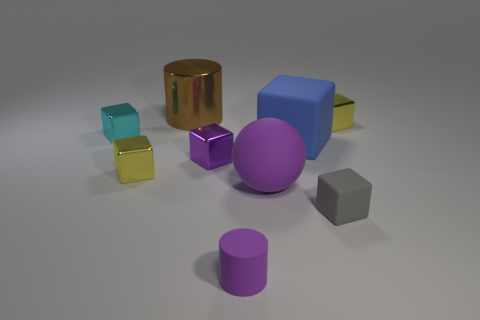What number of other objects are there of the same material as the large brown object?
Provide a succinct answer. 4. Is the material of the large cube the same as the yellow thing to the left of the large matte ball?
Your response must be concise. No. Is the number of big matte cubes that are behind the blue rubber cube less than the number of metal cubes on the left side of the small purple block?
Keep it short and to the point. Yes. There is a metal block behind the cyan thing; what color is it?
Provide a short and direct response. Yellow. How many other things are there of the same color as the large rubber block?
Keep it short and to the point. 0. There is a metallic block that is on the right side of the purple block; does it have the same size as the purple block?
Offer a very short reply. Yes. There is a cyan block; how many purple cubes are left of it?
Offer a very short reply. 0. Are there any other things that have the same size as the brown object?
Your answer should be compact. Yes. Do the large sphere and the tiny rubber cylinder have the same color?
Your response must be concise. Yes. There is a matte thing behind the small yellow object left of the gray rubber cube; what is its color?
Keep it short and to the point. Blue. 